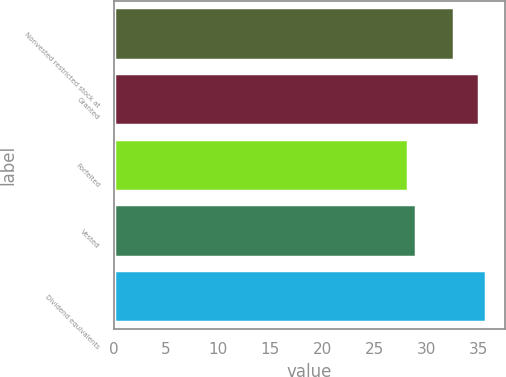Convert chart. <chart><loc_0><loc_0><loc_500><loc_500><bar_chart><fcel>Nonvested restricted stock at<fcel>Granted<fcel>Forfeited<fcel>Vested<fcel>Dividend equivalents<nl><fcel>32.62<fcel>35<fcel>28.24<fcel>28.93<fcel>35.7<nl></chart> 